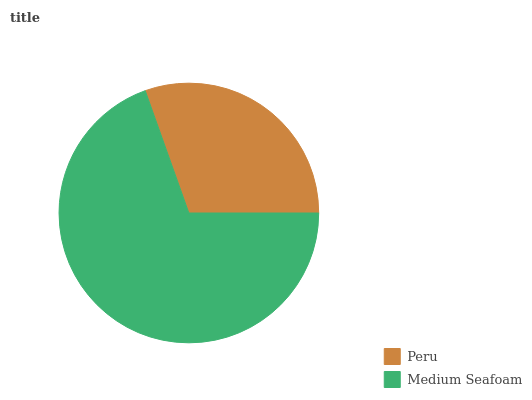Is Peru the minimum?
Answer yes or no. Yes. Is Medium Seafoam the maximum?
Answer yes or no. Yes. Is Medium Seafoam the minimum?
Answer yes or no. No. Is Medium Seafoam greater than Peru?
Answer yes or no. Yes. Is Peru less than Medium Seafoam?
Answer yes or no. Yes. Is Peru greater than Medium Seafoam?
Answer yes or no. No. Is Medium Seafoam less than Peru?
Answer yes or no. No. Is Medium Seafoam the high median?
Answer yes or no. Yes. Is Peru the low median?
Answer yes or no. Yes. Is Peru the high median?
Answer yes or no. No. Is Medium Seafoam the low median?
Answer yes or no. No. 